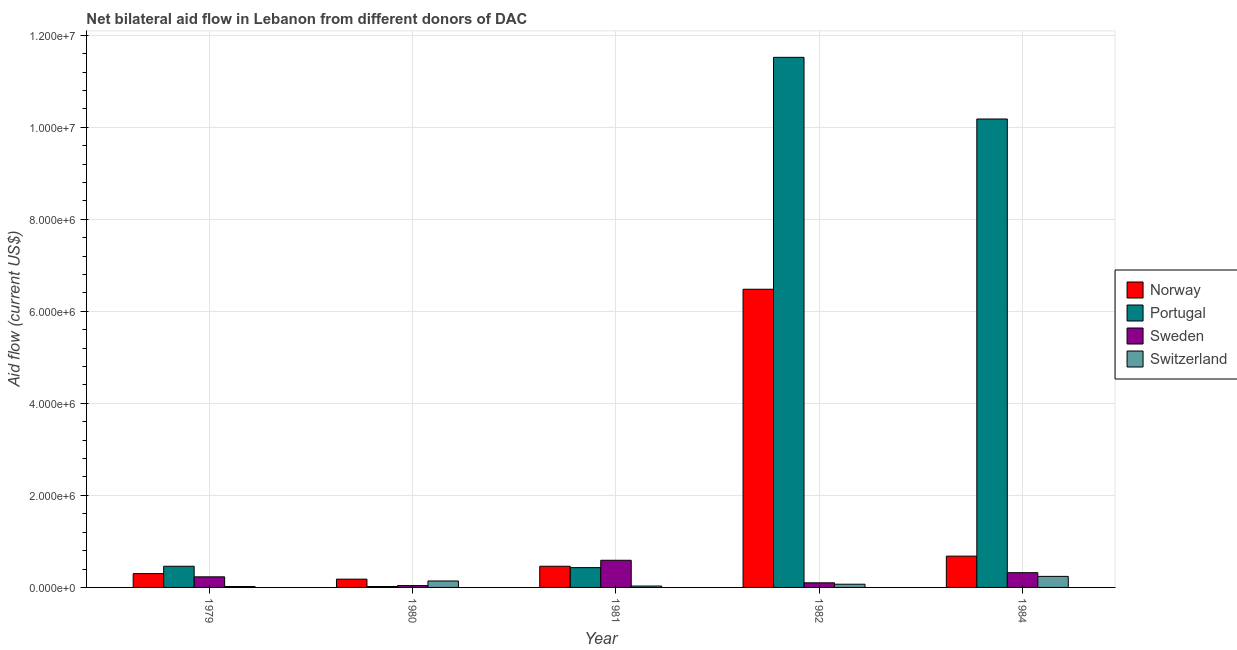How many groups of bars are there?
Your answer should be compact. 5. Are the number of bars per tick equal to the number of legend labels?
Provide a succinct answer. Yes. How many bars are there on the 4th tick from the left?
Ensure brevity in your answer.  4. How many bars are there on the 5th tick from the right?
Make the answer very short. 4. What is the label of the 1st group of bars from the left?
Offer a very short reply. 1979. What is the amount of aid given by portugal in 1982?
Your response must be concise. 1.15e+07. Across all years, what is the maximum amount of aid given by norway?
Ensure brevity in your answer.  6.48e+06. Across all years, what is the minimum amount of aid given by portugal?
Offer a terse response. 2.00e+04. In which year was the amount of aid given by sweden maximum?
Your answer should be very brief. 1981. In which year was the amount of aid given by switzerland minimum?
Give a very brief answer. 1979. What is the total amount of aid given by portugal in the graph?
Provide a succinct answer. 2.26e+07. What is the difference between the amount of aid given by sweden in 1980 and that in 1984?
Provide a succinct answer. -2.80e+05. What is the difference between the amount of aid given by switzerland in 1981 and the amount of aid given by portugal in 1980?
Your answer should be compact. -1.10e+05. What is the average amount of aid given by norway per year?
Your response must be concise. 1.62e+06. In the year 1981, what is the difference between the amount of aid given by sweden and amount of aid given by switzerland?
Keep it short and to the point. 0. What is the difference between the highest and the lowest amount of aid given by sweden?
Give a very brief answer. 5.50e+05. In how many years, is the amount of aid given by sweden greater than the average amount of aid given by sweden taken over all years?
Provide a short and direct response. 2. Is the sum of the amount of aid given by portugal in 1979 and 1981 greater than the maximum amount of aid given by sweden across all years?
Offer a very short reply. No. Is it the case that in every year, the sum of the amount of aid given by sweden and amount of aid given by switzerland is greater than the sum of amount of aid given by norway and amount of aid given by portugal?
Make the answer very short. No. What does the 4th bar from the left in 1982 represents?
Ensure brevity in your answer.  Switzerland. What does the 3rd bar from the right in 1982 represents?
Your response must be concise. Portugal. How many bars are there?
Your answer should be compact. 20. How many years are there in the graph?
Your response must be concise. 5. What is the difference between two consecutive major ticks on the Y-axis?
Ensure brevity in your answer.  2.00e+06. Does the graph contain any zero values?
Keep it short and to the point. No. What is the title of the graph?
Make the answer very short. Net bilateral aid flow in Lebanon from different donors of DAC. What is the label or title of the X-axis?
Ensure brevity in your answer.  Year. What is the label or title of the Y-axis?
Offer a very short reply. Aid flow (current US$). What is the Aid flow (current US$) in Portugal in 1979?
Your response must be concise. 4.60e+05. What is the Aid flow (current US$) of Switzerland in 1979?
Your response must be concise. 2.00e+04. What is the Aid flow (current US$) of Portugal in 1980?
Your answer should be compact. 2.00e+04. What is the Aid flow (current US$) in Sweden in 1980?
Offer a terse response. 4.00e+04. What is the Aid flow (current US$) in Switzerland in 1980?
Make the answer very short. 1.40e+05. What is the Aid flow (current US$) in Norway in 1981?
Ensure brevity in your answer.  4.60e+05. What is the Aid flow (current US$) of Portugal in 1981?
Provide a short and direct response. 4.30e+05. What is the Aid flow (current US$) of Sweden in 1981?
Your answer should be compact. 5.90e+05. What is the Aid flow (current US$) of Switzerland in 1981?
Give a very brief answer. 3.00e+04. What is the Aid flow (current US$) of Norway in 1982?
Offer a very short reply. 6.48e+06. What is the Aid flow (current US$) in Portugal in 1982?
Offer a very short reply. 1.15e+07. What is the Aid flow (current US$) in Sweden in 1982?
Ensure brevity in your answer.  1.00e+05. What is the Aid flow (current US$) of Norway in 1984?
Make the answer very short. 6.80e+05. What is the Aid flow (current US$) in Portugal in 1984?
Your answer should be very brief. 1.02e+07. What is the Aid flow (current US$) of Switzerland in 1984?
Your answer should be compact. 2.40e+05. Across all years, what is the maximum Aid flow (current US$) of Norway?
Give a very brief answer. 6.48e+06. Across all years, what is the maximum Aid flow (current US$) of Portugal?
Make the answer very short. 1.15e+07. Across all years, what is the maximum Aid flow (current US$) of Sweden?
Give a very brief answer. 5.90e+05. Across all years, what is the maximum Aid flow (current US$) in Switzerland?
Offer a terse response. 2.40e+05. Across all years, what is the minimum Aid flow (current US$) in Norway?
Provide a succinct answer. 1.80e+05. Across all years, what is the minimum Aid flow (current US$) of Portugal?
Keep it short and to the point. 2.00e+04. What is the total Aid flow (current US$) in Norway in the graph?
Your answer should be very brief. 8.10e+06. What is the total Aid flow (current US$) of Portugal in the graph?
Your answer should be compact. 2.26e+07. What is the total Aid flow (current US$) of Sweden in the graph?
Ensure brevity in your answer.  1.28e+06. What is the difference between the Aid flow (current US$) in Portugal in 1979 and that in 1980?
Ensure brevity in your answer.  4.40e+05. What is the difference between the Aid flow (current US$) of Sweden in 1979 and that in 1981?
Offer a terse response. -3.60e+05. What is the difference between the Aid flow (current US$) of Norway in 1979 and that in 1982?
Your answer should be very brief. -6.18e+06. What is the difference between the Aid flow (current US$) of Portugal in 1979 and that in 1982?
Provide a short and direct response. -1.11e+07. What is the difference between the Aid flow (current US$) of Norway in 1979 and that in 1984?
Make the answer very short. -3.80e+05. What is the difference between the Aid flow (current US$) of Portugal in 1979 and that in 1984?
Give a very brief answer. -9.72e+06. What is the difference between the Aid flow (current US$) of Norway in 1980 and that in 1981?
Offer a terse response. -2.80e+05. What is the difference between the Aid flow (current US$) in Portugal in 1980 and that in 1981?
Make the answer very short. -4.10e+05. What is the difference between the Aid flow (current US$) in Sweden in 1980 and that in 1981?
Provide a succinct answer. -5.50e+05. What is the difference between the Aid flow (current US$) in Switzerland in 1980 and that in 1981?
Your answer should be compact. 1.10e+05. What is the difference between the Aid flow (current US$) of Norway in 1980 and that in 1982?
Your answer should be very brief. -6.30e+06. What is the difference between the Aid flow (current US$) in Portugal in 1980 and that in 1982?
Offer a terse response. -1.15e+07. What is the difference between the Aid flow (current US$) in Switzerland in 1980 and that in 1982?
Keep it short and to the point. 7.00e+04. What is the difference between the Aid flow (current US$) in Norway in 1980 and that in 1984?
Offer a terse response. -5.00e+05. What is the difference between the Aid flow (current US$) in Portugal in 1980 and that in 1984?
Provide a succinct answer. -1.02e+07. What is the difference between the Aid flow (current US$) of Sweden in 1980 and that in 1984?
Your answer should be compact. -2.80e+05. What is the difference between the Aid flow (current US$) of Norway in 1981 and that in 1982?
Keep it short and to the point. -6.02e+06. What is the difference between the Aid flow (current US$) of Portugal in 1981 and that in 1982?
Offer a very short reply. -1.11e+07. What is the difference between the Aid flow (current US$) in Portugal in 1981 and that in 1984?
Your answer should be compact. -9.75e+06. What is the difference between the Aid flow (current US$) of Sweden in 1981 and that in 1984?
Ensure brevity in your answer.  2.70e+05. What is the difference between the Aid flow (current US$) in Switzerland in 1981 and that in 1984?
Keep it short and to the point. -2.10e+05. What is the difference between the Aid flow (current US$) in Norway in 1982 and that in 1984?
Your answer should be very brief. 5.80e+06. What is the difference between the Aid flow (current US$) of Portugal in 1982 and that in 1984?
Ensure brevity in your answer.  1.34e+06. What is the difference between the Aid flow (current US$) of Switzerland in 1982 and that in 1984?
Offer a terse response. -1.70e+05. What is the difference between the Aid flow (current US$) of Portugal in 1979 and the Aid flow (current US$) of Sweden in 1980?
Keep it short and to the point. 4.20e+05. What is the difference between the Aid flow (current US$) of Portugal in 1979 and the Aid flow (current US$) of Switzerland in 1980?
Provide a short and direct response. 3.20e+05. What is the difference between the Aid flow (current US$) in Sweden in 1979 and the Aid flow (current US$) in Switzerland in 1980?
Provide a succinct answer. 9.00e+04. What is the difference between the Aid flow (current US$) in Norway in 1979 and the Aid flow (current US$) in Sweden in 1981?
Offer a terse response. -2.90e+05. What is the difference between the Aid flow (current US$) in Portugal in 1979 and the Aid flow (current US$) in Sweden in 1981?
Make the answer very short. -1.30e+05. What is the difference between the Aid flow (current US$) of Portugal in 1979 and the Aid flow (current US$) of Switzerland in 1981?
Provide a short and direct response. 4.30e+05. What is the difference between the Aid flow (current US$) of Sweden in 1979 and the Aid flow (current US$) of Switzerland in 1981?
Provide a succinct answer. 2.00e+05. What is the difference between the Aid flow (current US$) in Norway in 1979 and the Aid flow (current US$) in Portugal in 1982?
Provide a short and direct response. -1.12e+07. What is the difference between the Aid flow (current US$) in Norway in 1979 and the Aid flow (current US$) in Sweden in 1982?
Offer a very short reply. 2.00e+05. What is the difference between the Aid flow (current US$) in Norway in 1979 and the Aid flow (current US$) in Switzerland in 1982?
Offer a very short reply. 2.30e+05. What is the difference between the Aid flow (current US$) of Portugal in 1979 and the Aid flow (current US$) of Switzerland in 1982?
Your answer should be very brief. 3.90e+05. What is the difference between the Aid flow (current US$) in Norway in 1979 and the Aid flow (current US$) in Portugal in 1984?
Make the answer very short. -9.88e+06. What is the difference between the Aid flow (current US$) of Portugal in 1979 and the Aid flow (current US$) of Sweden in 1984?
Your response must be concise. 1.40e+05. What is the difference between the Aid flow (current US$) of Norway in 1980 and the Aid flow (current US$) of Sweden in 1981?
Give a very brief answer. -4.10e+05. What is the difference between the Aid flow (current US$) in Norway in 1980 and the Aid flow (current US$) in Switzerland in 1981?
Provide a succinct answer. 1.50e+05. What is the difference between the Aid flow (current US$) of Portugal in 1980 and the Aid flow (current US$) of Sweden in 1981?
Your answer should be very brief. -5.70e+05. What is the difference between the Aid flow (current US$) of Portugal in 1980 and the Aid flow (current US$) of Switzerland in 1981?
Provide a succinct answer. -10000. What is the difference between the Aid flow (current US$) of Norway in 1980 and the Aid flow (current US$) of Portugal in 1982?
Offer a very short reply. -1.13e+07. What is the difference between the Aid flow (current US$) in Norway in 1980 and the Aid flow (current US$) in Sweden in 1982?
Provide a short and direct response. 8.00e+04. What is the difference between the Aid flow (current US$) of Norway in 1980 and the Aid flow (current US$) of Switzerland in 1982?
Provide a short and direct response. 1.10e+05. What is the difference between the Aid flow (current US$) of Portugal in 1980 and the Aid flow (current US$) of Switzerland in 1982?
Keep it short and to the point. -5.00e+04. What is the difference between the Aid flow (current US$) of Norway in 1980 and the Aid flow (current US$) of Portugal in 1984?
Your answer should be compact. -1.00e+07. What is the difference between the Aid flow (current US$) of Norway in 1980 and the Aid flow (current US$) of Sweden in 1984?
Provide a succinct answer. -1.40e+05. What is the difference between the Aid flow (current US$) in Portugal in 1980 and the Aid flow (current US$) in Sweden in 1984?
Your answer should be compact. -3.00e+05. What is the difference between the Aid flow (current US$) in Norway in 1981 and the Aid flow (current US$) in Portugal in 1982?
Make the answer very short. -1.11e+07. What is the difference between the Aid flow (current US$) of Norway in 1981 and the Aid flow (current US$) of Sweden in 1982?
Make the answer very short. 3.60e+05. What is the difference between the Aid flow (current US$) in Norway in 1981 and the Aid flow (current US$) in Switzerland in 1982?
Provide a short and direct response. 3.90e+05. What is the difference between the Aid flow (current US$) in Portugal in 1981 and the Aid flow (current US$) in Sweden in 1982?
Your answer should be very brief. 3.30e+05. What is the difference between the Aid flow (current US$) in Sweden in 1981 and the Aid flow (current US$) in Switzerland in 1982?
Make the answer very short. 5.20e+05. What is the difference between the Aid flow (current US$) of Norway in 1981 and the Aid flow (current US$) of Portugal in 1984?
Provide a succinct answer. -9.72e+06. What is the difference between the Aid flow (current US$) in Portugal in 1981 and the Aid flow (current US$) in Sweden in 1984?
Offer a terse response. 1.10e+05. What is the difference between the Aid flow (current US$) of Sweden in 1981 and the Aid flow (current US$) of Switzerland in 1984?
Your response must be concise. 3.50e+05. What is the difference between the Aid flow (current US$) of Norway in 1982 and the Aid flow (current US$) of Portugal in 1984?
Give a very brief answer. -3.70e+06. What is the difference between the Aid flow (current US$) of Norway in 1982 and the Aid flow (current US$) of Sweden in 1984?
Offer a terse response. 6.16e+06. What is the difference between the Aid flow (current US$) in Norway in 1982 and the Aid flow (current US$) in Switzerland in 1984?
Offer a terse response. 6.24e+06. What is the difference between the Aid flow (current US$) in Portugal in 1982 and the Aid flow (current US$) in Sweden in 1984?
Make the answer very short. 1.12e+07. What is the difference between the Aid flow (current US$) of Portugal in 1982 and the Aid flow (current US$) of Switzerland in 1984?
Keep it short and to the point. 1.13e+07. What is the average Aid flow (current US$) of Norway per year?
Your response must be concise. 1.62e+06. What is the average Aid flow (current US$) in Portugal per year?
Give a very brief answer. 4.52e+06. What is the average Aid flow (current US$) of Sweden per year?
Your response must be concise. 2.56e+05. What is the average Aid flow (current US$) of Switzerland per year?
Offer a very short reply. 1.00e+05. In the year 1979, what is the difference between the Aid flow (current US$) in Norway and Aid flow (current US$) in Portugal?
Your answer should be compact. -1.60e+05. In the year 1979, what is the difference between the Aid flow (current US$) in Norway and Aid flow (current US$) in Sweden?
Offer a terse response. 7.00e+04. In the year 1979, what is the difference between the Aid flow (current US$) in Norway and Aid flow (current US$) in Switzerland?
Your response must be concise. 2.80e+05. In the year 1979, what is the difference between the Aid flow (current US$) of Portugal and Aid flow (current US$) of Sweden?
Give a very brief answer. 2.30e+05. In the year 1979, what is the difference between the Aid flow (current US$) of Sweden and Aid flow (current US$) of Switzerland?
Offer a very short reply. 2.10e+05. In the year 1980, what is the difference between the Aid flow (current US$) of Norway and Aid flow (current US$) of Portugal?
Make the answer very short. 1.60e+05. In the year 1980, what is the difference between the Aid flow (current US$) of Norway and Aid flow (current US$) of Sweden?
Offer a very short reply. 1.40e+05. In the year 1980, what is the difference between the Aid flow (current US$) in Portugal and Aid flow (current US$) in Switzerland?
Provide a short and direct response. -1.20e+05. In the year 1980, what is the difference between the Aid flow (current US$) of Sweden and Aid flow (current US$) of Switzerland?
Offer a terse response. -1.00e+05. In the year 1981, what is the difference between the Aid flow (current US$) in Norway and Aid flow (current US$) in Portugal?
Your answer should be compact. 3.00e+04. In the year 1981, what is the difference between the Aid flow (current US$) of Norway and Aid flow (current US$) of Switzerland?
Make the answer very short. 4.30e+05. In the year 1981, what is the difference between the Aid flow (current US$) of Portugal and Aid flow (current US$) of Sweden?
Your answer should be very brief. -1.60e+05. In the year 1981, what is the difference between the Aid flow (current US$) in Portugal and Aid flow (current US$) in Switzerland?
Offer a very short reply. 4.00e+05. In the year 1981, what is the difference between the Aid flow (current US$) of Sweden and Aid flow (current US$) of Switzerland?
Provide a short and direct response. 5.60e+05. In the year 1982, what is the difference between the Aid flow (current US$) of Norway and Aid flow (current US$) of Portugal?
Your answer should be compact. -5.04e+06. In the year 1982, what is the difference between the Aid flow (current US$) in Norway and Aid flow (current US$) in Sweden?
Keep it short and to the point. 6.38e+06. In the year 1982, what is the difference between the Aid flow (current US$) of Norway and Aid flow (current US$) of Switzerland?
Make the answer very short. 6.41e+06. In the year 1982, what is the difference between the Aid flow (current US$) of Portugal and Aid flow (current US$) of Sweden?
Offer a very short reply. 1.14e+07. In the year 1982, what is the difference between the Aid flow (current US$) of Portugal and Aid flow (current US$) of Switzerland?
Ensure brevity in your answer.  1.14e+07. In the year 1982, what is the difference between the Aid flow (current US$) in Sweden and Aid flow (current US$) in Switzerland?
Provide a short and direct response. 3.00e+04. In the year 1984, what is the difference between the Aid flow (current US$) of Norway and Aid flow (current US$) of Portugal?
Your answer should be compact. -9.50e+06. In the year 1984, what is the difference between the Aid flow (current US$) in Norway and Aid flow (current US$) in Sweden?
Your answer should be compact. 3.60e+05. In the year 1984, what is the difference between the Aid flow (current US$) of Norway and Aid flow (current US$) of Switzerland?
Provide a short and direct response. 4.40e+05. In the year 1984, what is the difference between the Aid flow (current US$) of Portugal and Aid flow (current US$) of Sweden?
Make the answer very short. 9.86e+06. In the year 1984, what is the difference between the Aid flow (current US$) of Portugal and Aid flow (current US$) of Switzerland?
Offer a terse response. 9.94e+06. In the year 1984, what is the difference between the Aid flow (current US$) in Sweden and Aid flow (current US$) in Switzerland?
Provide a short and direct response. 8.00e+04. What is the ratio of the Aid flow (current US$) in Sweden in 1979 to that in 1980?
Keep it short and to the point. 5.75. What is the ratio of the Aid flow (current US$) in Switzerland in 1979 to that in 1980?
Give a very brief answer. 0.14. What is the ratio of the Aid flow (current US$) of Norway in 1979 to that in 1981?
Offer a very short reply. 0.65. What is the ratio of the Aid flow (current US$) of Portugal in 1979 to that in 1981?
Keep it short and to the point. 1.07. What is the ratio of the Aid flow (current US$) in Sweden in 1979 to that in 1981?
Provide a succinct answer. 0.39. What is the ratio of the Aid flow (current US$) in Switzerland in 1979 to that in 1981?
Your answer should be very brief. 0.67. What is the ratio of the Aid flow (current US$) in Norway in 1979 to that in 1982?
Provide a succinct answer. 0.05. What is the ratio of the Aid flow (current US$) in Portugal in 1979 to that in 1982?
Provide a succinct answer. 0.04. What is the ratio of the Aid flow (current US$) of Switzerland in 1979 to that in 1982?
Provide a short and direct response. 0.29. What is the ratio of the Aid flow (current US$) of Norway in 1979 to that in 1984?
Keep it short and to the point. 0.44. What is the ratio of the Aid flow (current US$) of Portugal in 1979 to that in 1984?
Your answer should be very brief. 0.05. What is the ratio of the Aid flow (current US$) of Sweden in 1979 to that in 1984?
Offer a terse response. 0.72. What is the ratio of the Aid flow (current US$) in Switzerland in 1979 to that in 1984?
Offer a very short reply. 0.08. What is the ratio of the Aid flow (current US$) of Norway in 1980 to that in 1981?
Make the answer very short. 0.39. What is the ratio of the Aid flow (current US$) of Portugal in 1980 to that in 1981?
Provide a short and direct response. 0.05. What is the ratio of the Aid flow (current US$) in Sweden in 1980 to that in 1981?
Your response must be concise. 0.07. What is the ratio of the Aid flow (current US$) in Switzerland in 1980 to that in 1981?
Offer a terse response. 4.67. What is the ratio of the Aid flow (current US$) of Norway in 1980 to that in 1982?
Offer a terse response. 0.03. What is the ratio of the Aid flow (current US$) of Portugal in 1980 to that in 1982?
Ensure brevity in your answer.  0. What is the ratio of the Aid flow (current US$) of Switzerland in 1980 to that in 1982?
Offer a terse response. 2. What is the ratio of the Aid flow (current US$) in Norway in 1980 to that in 1984?
Offer a terse response. 0.26. What is the ratio of the Aid flow (current US$) in Portugal in 1980 to that in 1984?
Your answer should be very brief. 0. What is the ratio of the Aid flow (current US$) in Sweden in 1980 to that in 1984?
Give a very brief answer. 0.12. What is the ratio of the Aid flow (current US$) in Switzerland in 1980 to that in 1984?
Give a very brief answer. 0.58. What is the ratio of the Aid flow (current US$) of Norway in 1981 to that in 1982?
Keep it short and to the point. 0.07. What is the ratio of the Aid flow (current US$) in Portugal in 1981 to that in 1982?
Offer a very short reply. 0.04. What is the ratio of the Aid flow (current US$) of Switzerland in 1981 to that in 1982?
Keep it short and to the point. 0.43. What is the ratio of the Aid flow (current US$) of Norway in 1981 to that in 1984?
Your answer should be compact. 0.68. What is the ratio of the Aid flow (current US$) of Portugal in 1981 to that in 1984?
Make the answer very short. 0.04. What is the ratio of the Aid flow (current US$) of Sweden in 1981 to that in 1984?
Your answer should be compact. 1.84. What is the ratio of the Aid flow (current US$) of Norway in 1982 to that in 1984?
Offer a terse response. 9.53. What is the ratio of the Aid flow (current US$) of Portugal in 1982 to that in 1984?
Provide a succinct answer. 1.13. What is the ratio of the Aid flow (current US$) in Sweden in 1982 to that in 1984?
Your answer should be very brief. 0.31. What is the ratio of the Aid flow (current US$) of Switzerland in 1982 to that in 1984?
Offer a terse response. 0.29. What is the difference between the highest and the second highest Aid flow (current US$) of Norway?
Your answer should be very brief. 5.80e+06. What is the difference between the highest and the second highest Aid flow (current US$) in Portugal?
Provide a succinct answer. 1.34e+06. What is the difference between the highest and the second highest Aid flow (current US$) of Switzerland?
Your answer should be compact. 1.00e+05. What is the difference between the highest and the lowest Aid flow (current US$) of Norway?
Give a very brief answer. 6.30e+06. What is the difference between the highest and the lowest Aid flow (current US$) in Portugal?
Your answer should be compact. 1.15e+07. What is the difference between the highest and the lowest Aid flow (current US$) in Sweden?
Your answer should be very brief. 5.50e+05. What is the difference between the highest and the lowest Aid flow (current US$) of Switzerland?
Make the answer very short. 2.20e+05. 